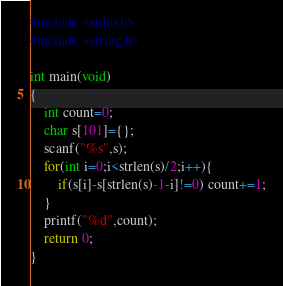<code> <loc_0><loc_0><loc_500><loc_500><_C_>#include <stdio.h>
#include <string.h>

int main(void)
{
    int count=0;
    char s[101]={};
    scanf("%s",s);
    for(int i=0;i<strlen(s)/2;i++){
        if(s[i]-s[strlen(s)-1-i]!=0) count+=1;
    }
    printf("%d",count);
    return 0;
}
</code> 